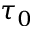Convert formula to latex. <formula><loc_0><loc_0><loc_500><loc_500>\tau _ { 0 }</formula> 